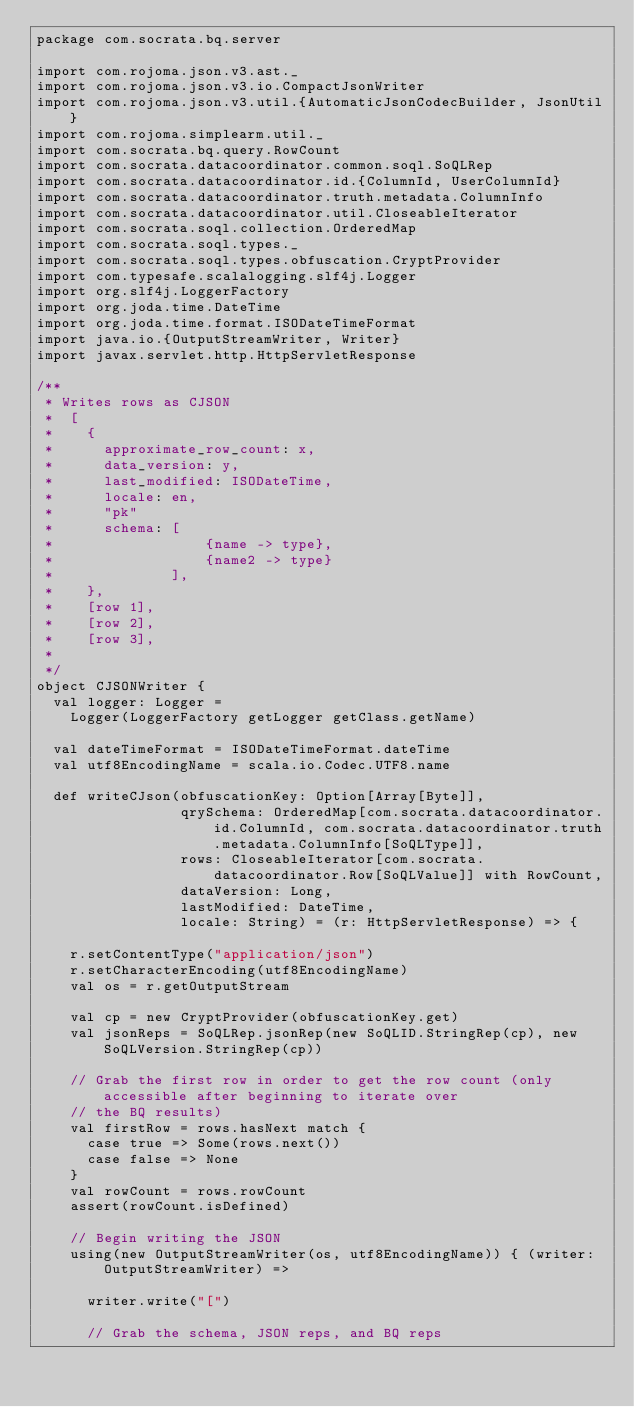<code> <loc_0><loc_0><loc_500><loc_500><_Scala_>package com.socrata.bq.server

import com.rojoma.json.v3.ast._
import com.rojoma.json.v3.io.CompactJsonWriter
import com.rojoma.json.v3.util.{AutomaticJsonCodecBuilder, JsonUtil}
import com.rojoma.simplearm.util._
import com.socrata.bq.query.RowCount
import com.socrata.datacoordinator.common.soql.SoQLRep
import com.socrata.datacoordinator.id.{ColumnId, UserColumnId}
import com.socrata.datacoordinator.truth.metadata.ColumnInfo
import com.socrata.datacoordinator.util.CloseableIterator
import com.socrata.soql.collection.OrderedMap
import com.socrata.soql.types._
import com.socrata.soql.types.obfuscation.CryptProvider
import com.typesafe.scalalogging.slf4j.Logger
import org.slf4j.LoggerFactory
import org.joda.time.DateTime
import org.joda.time.format.ISODateTimeFormat
import java.io.{OutputStreamWriter, Writer}
import javax.servlet.http.HttpServletResponse

/**
 * Writes rows as CJSON
 *  [
 *    {
 *      approximate_row_count: x,
 *      data_version: y,
 *      last_modified: ISODateTime,
 *      locale: en,
 *      "pk"
 *      schema: [
 *                  {name -> type},
 *                  {name2 -> type}
 *              ],
 *    },
 *    [row 1],
 *    [row 2],
 *    [row 3],
 *
 */
object CJSONWriter {
  val logger: Logger =
    Logger(LoggerFactory getLogger getClass.getName)

  val dateTimeFormat = ISODateTimeFormat.dateTime
  val utf8EncodingName = scala.io.Codec.UTF8.name

  def writeCJson(obfuscationKey: Option[Array[Byte]],
                 qrySchema: OrderedMap[com.socrata.datacoordinator.id.ColumnId, com.socrata.datacoordinator.truth.metadata.ColumnInfo[SoQLType]],
                 rows: CloseableIterator[com.socrata.datacoordinator.Row[SoQLValue]] with RowCount,
                 dataVersion: Long,
                 lastModified: DateTime,
                 locale: String) = (r: HttpServletResponse) => {

    r.setContentType("application/json")
    r.setCharacterEncoding(utf8EncodingName)
    val os = r.getOutputStream

    val cp = new CryptProvider(obfuscationKey.get)
    val jsonReps = SoQLRep.jsonRep(new SoQLID.StringRep(cp), new SoQLVersion.StringRep(cp))

    // Grab the first row in order to get the row count (only accessible after beginning to iterate over
    // the BQ results)
    val firstRow = rows.hasNext match {
      case true => Some(rows.next())
      case false => None
    }
    val rowCount = rows.rowCount
    assert(rowCount.isDefined)

    // Begin writing the JSON
    using(new OutputStreamWriter(os, utf8EncodingName)) { (writer: OutputStreamWriter) =>

      writer.write("[")

      // Grab the schema, JSON reps, and BQ reps</code> 